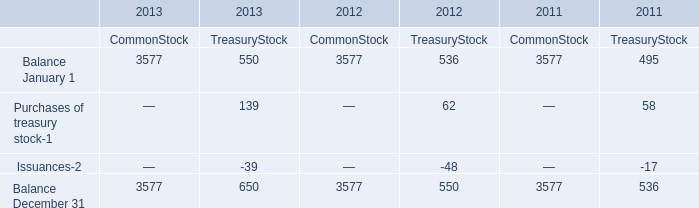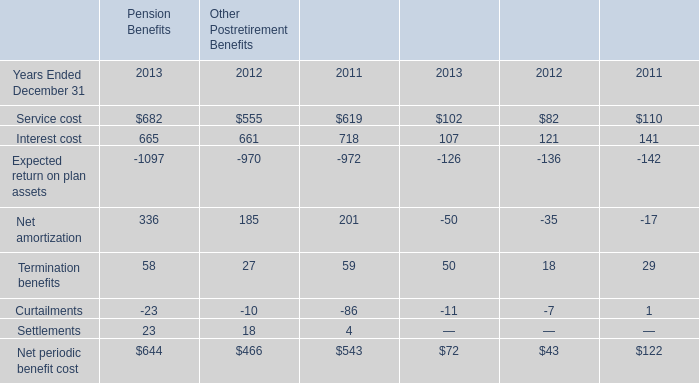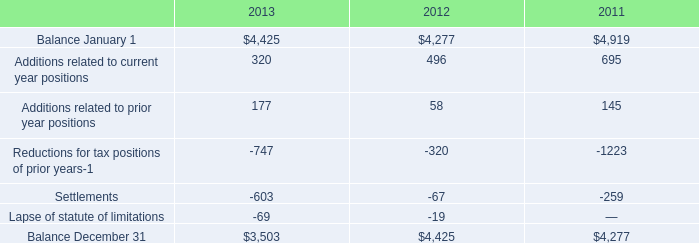What is the average amount of Balance December 31 of 2011 CommonStock, and Balance January 1 of 2013 ? 
Computations: ((3577.0 + 4425.0) / 2)
Answer: 4001.0. 